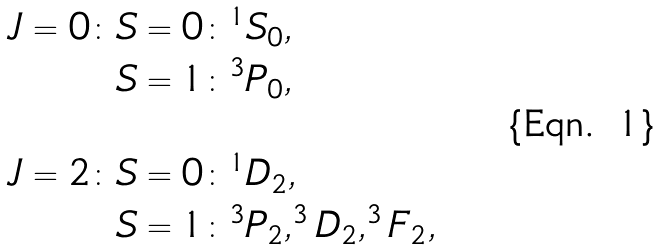Convert formula to latex. <formula><loc_0><loc_0><loc_500><loc_500>J = 0 \colon & S = 0 \colon ^ { 1 } S _ { 0 } , \\ & S = 1 \colon ^ { 3 } P _ { 0 } , \\ \\ J = 2 \colon & S = 0 \colon ^ { 1 } D _ { 2 } , \\ & S = 1 \colon ^ { 3 } P _ { 2 } , ^ { 3 } D _ { 2 } , ^ { 3 } F _ { 2 } , \\</formula> 